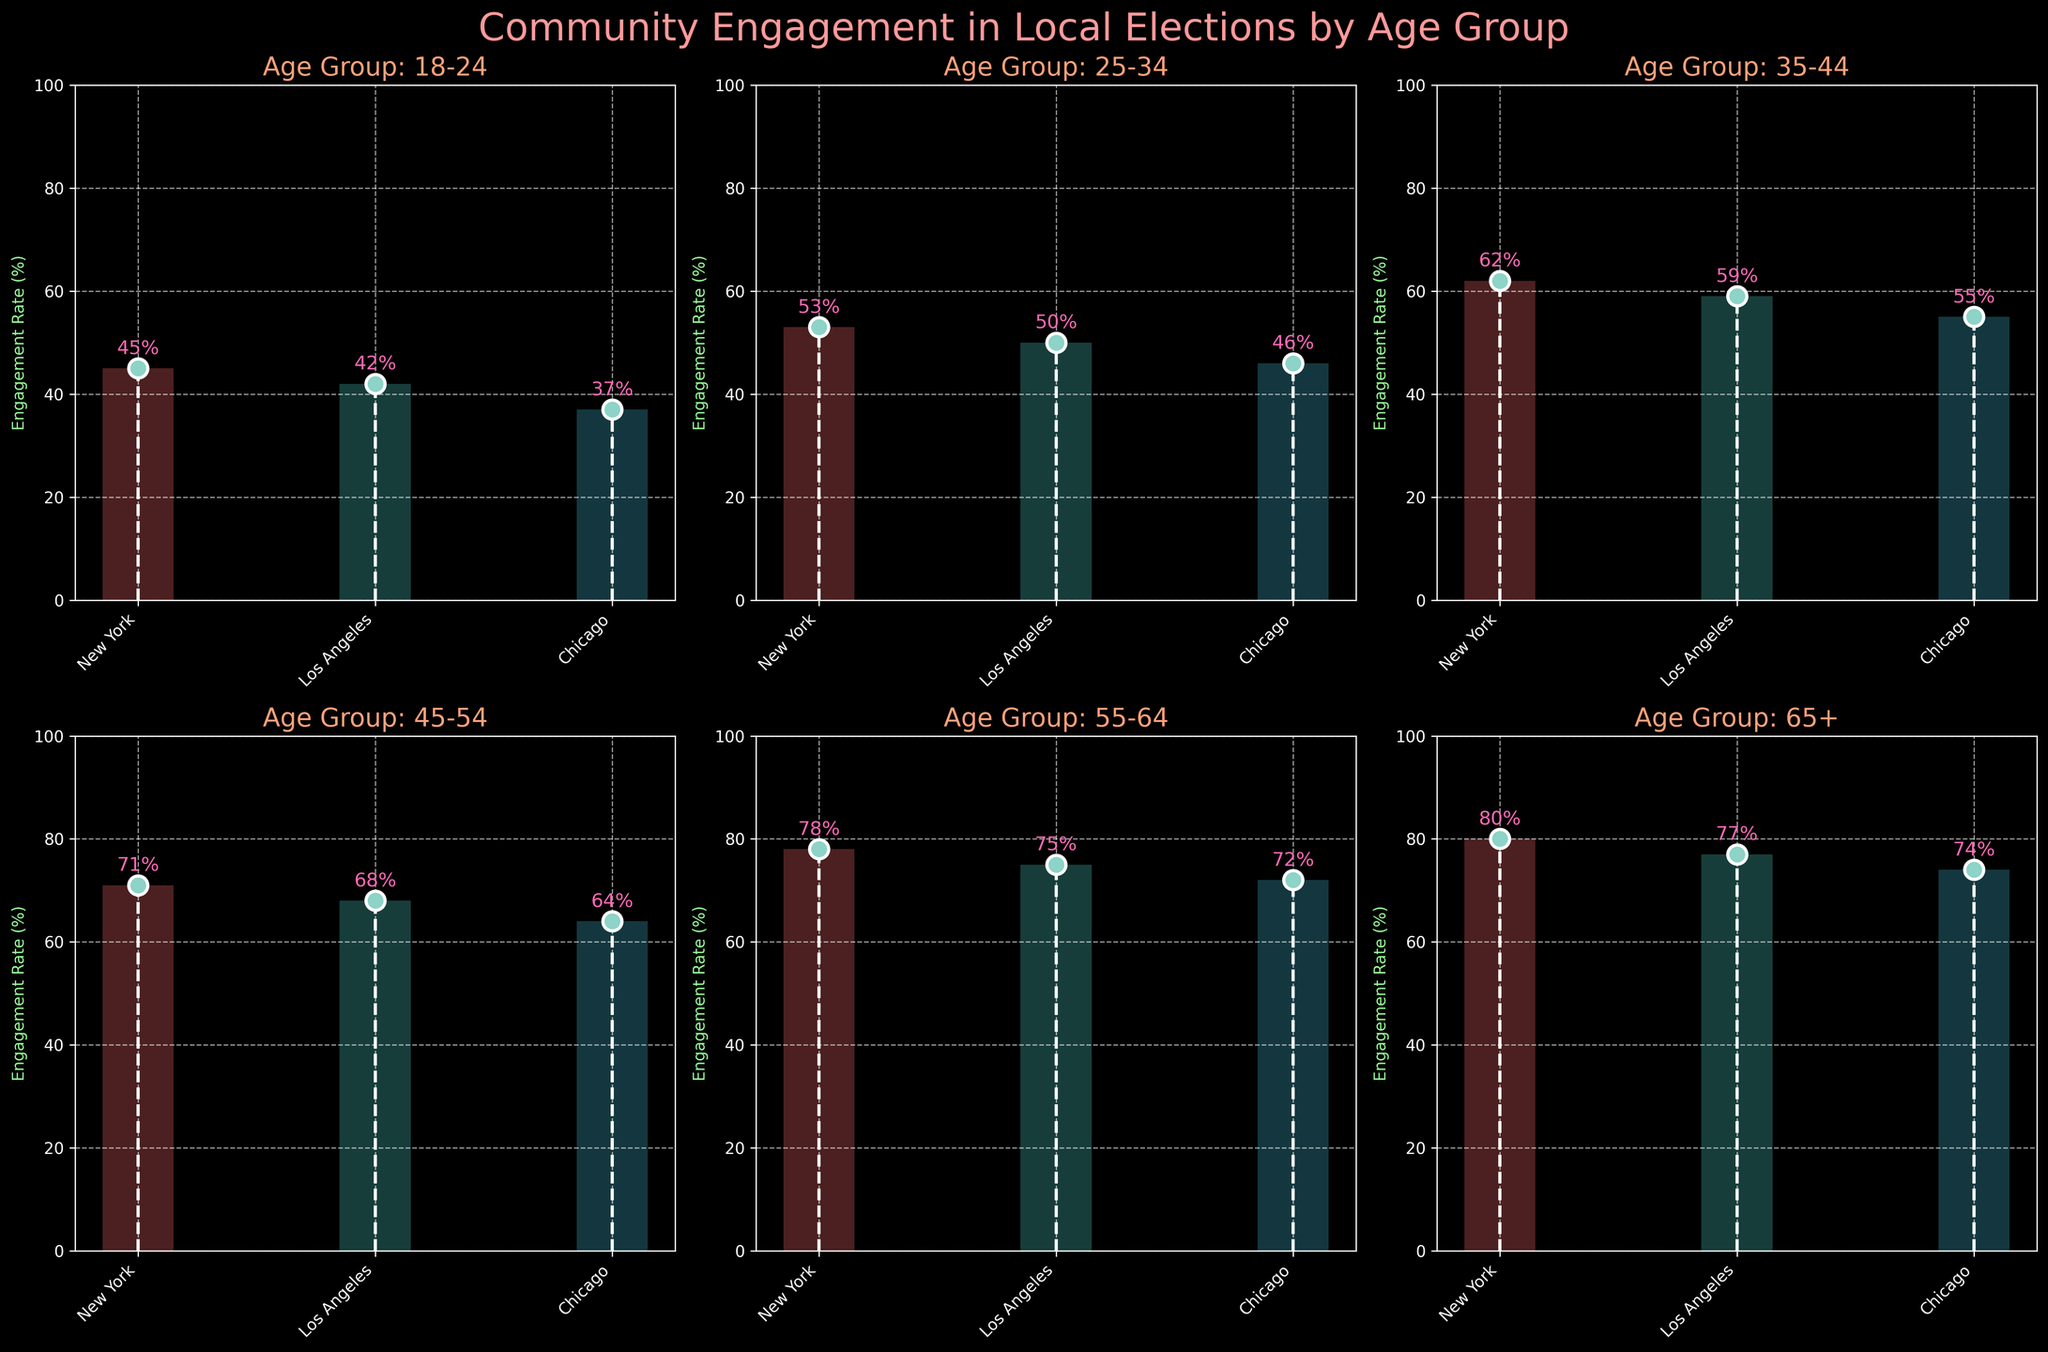What is the engagement rate for the age group 18-24 in Chicago? The subplot for the age group 18-24 displays the engagement rate, and the bar corresponding to Chicago indicates this value is highlighted beside the stem line.
Answer: 37% Which age group in New York has the highest engagement rate? By comparing the engagement rates for New York across all subplots, the 65+ age group has the highest value of 80%.
Answer: 65+ What is the difference in engagement rate between the age groups 25-34 and 45-54 in Los Angeles? From the subplot for Los Angeles, subtract the engagement rate of the 25-34 age group (50%) from the 45-54 age group (68%): 68% - 50% = 18%.
Answer: 18% How does the engagement rate for the 55-64 age group in Chicago compare to Los Angeles? The engagement rate for the 55-64 age group in Chicago is 72% and in Los Angeles is 75%. By comparing these, the rate in Los Angeles is higher.
Answer: Los Angeles is higher What is the average engagement rate for all cities in the age group 35-44? Add up the engagement rates for New York (62%), Los Angeles (59%), and Chicago (55%), then divide by the number of cities: (62 + 59 + 55) / 3 = 176 / 3 = 58.67%.
Answer: 58.67% Which city shows the lowest engagement rate for any age group? By examining all subplots, the lowest engagement rate observed is for the age group 18-24 in Chicago, which has a rate of 37%.
Answer: Chicago for age group 18-24 Is there a city where the engagement rate consistently increases with age group? Checking each subplot, New York shows a consistent increase in engagement rate as the age group rises from 18-24 (45%) to 65+ (80%).
Answer: New York 